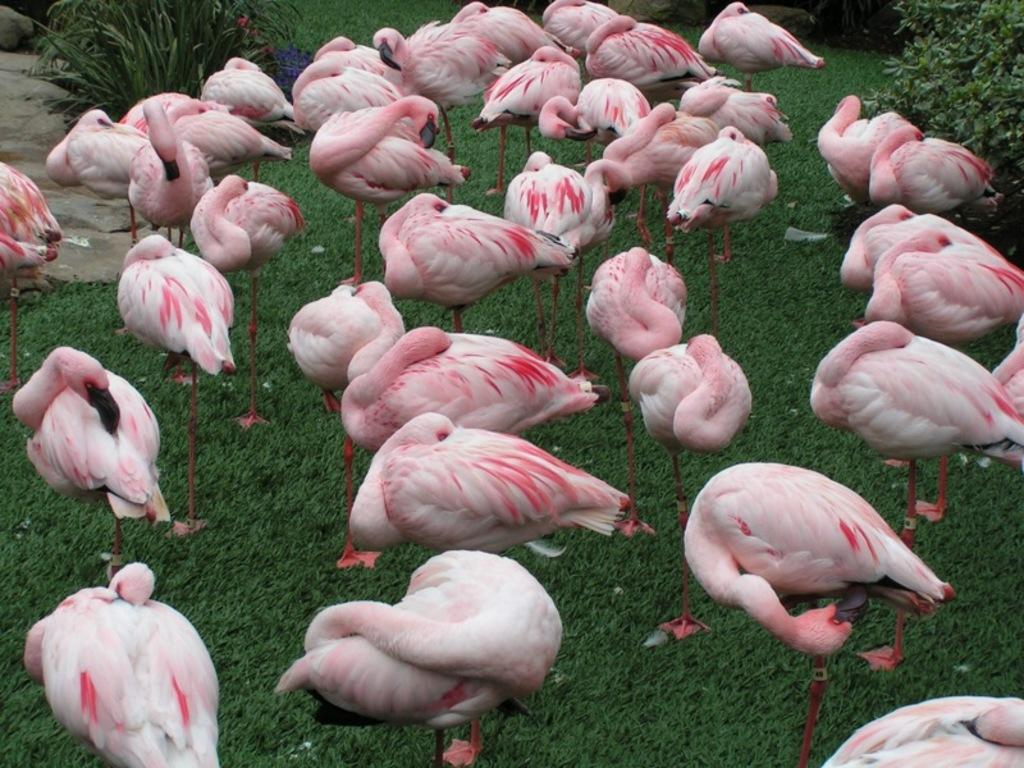What type of animals are in the image? There is a group of birds in the image. Where are the birds located? The birds are on the grass. What can be seen in the background of the image? There are stones and plants visible in the background of the image. What type of cent is visible in the image? There is no cent present in the image. What kind of seed can be seen growing on the grass? There is no seed visible in the image; it only shows a group of birds on the grass. 